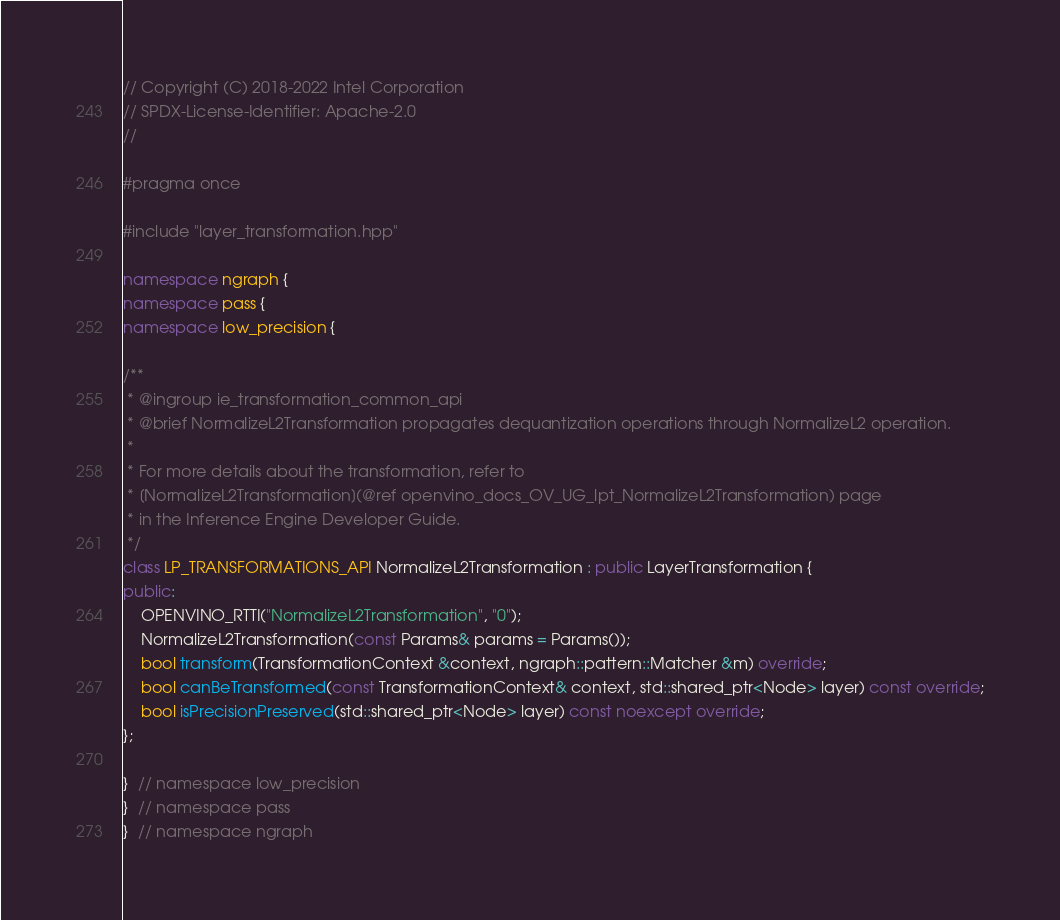<code> <loc_0><loc_0><loc_500><loc_500><_C++_>// Copyright (C) 2018-2022 Intel Corporation
// SPDX-License-Identifier: Apache-2.0
//

#pragma once

#include "layer_transformation.hpp"

namespace ngraph {
namespace pass {
namespace low_precision {

/**
 * @ingroup ie_transformation_common_api
 * @brief NormalizeL2Transformation propagates dequantization operations through NormalizeL2 operation.
 *
 * For more details about the transformation, refer to
 * [NormalizeL2Transformation](@ref openvino_docs_OV_UG_lpt_NormalizeL2Transformation) page
 * in the Inference Engine Developer Guide.
 */
class LP_TRANSFORMATIONS_API NormalizeL2Transformation : public LayerTransformation {
public:
    OPENVINO_RTTI("NormalizeL2Transformation", "0");
    NormalizeL2Transformation(const Params& params = Params());
    bool transform(TransformationContext &context, ngraph::pattern::Matcher &m) override;
    bool canBeTransformed(const TransformationContext& context, std::shared_ptr<Node> layer) const override;
    bool isPrecisionPreserved(std::shared_ptr<Node> layer) const noexcept override;
};

}  // namespace low_precision
}  // namespace pass
}  // namespace ngraph
</code> 